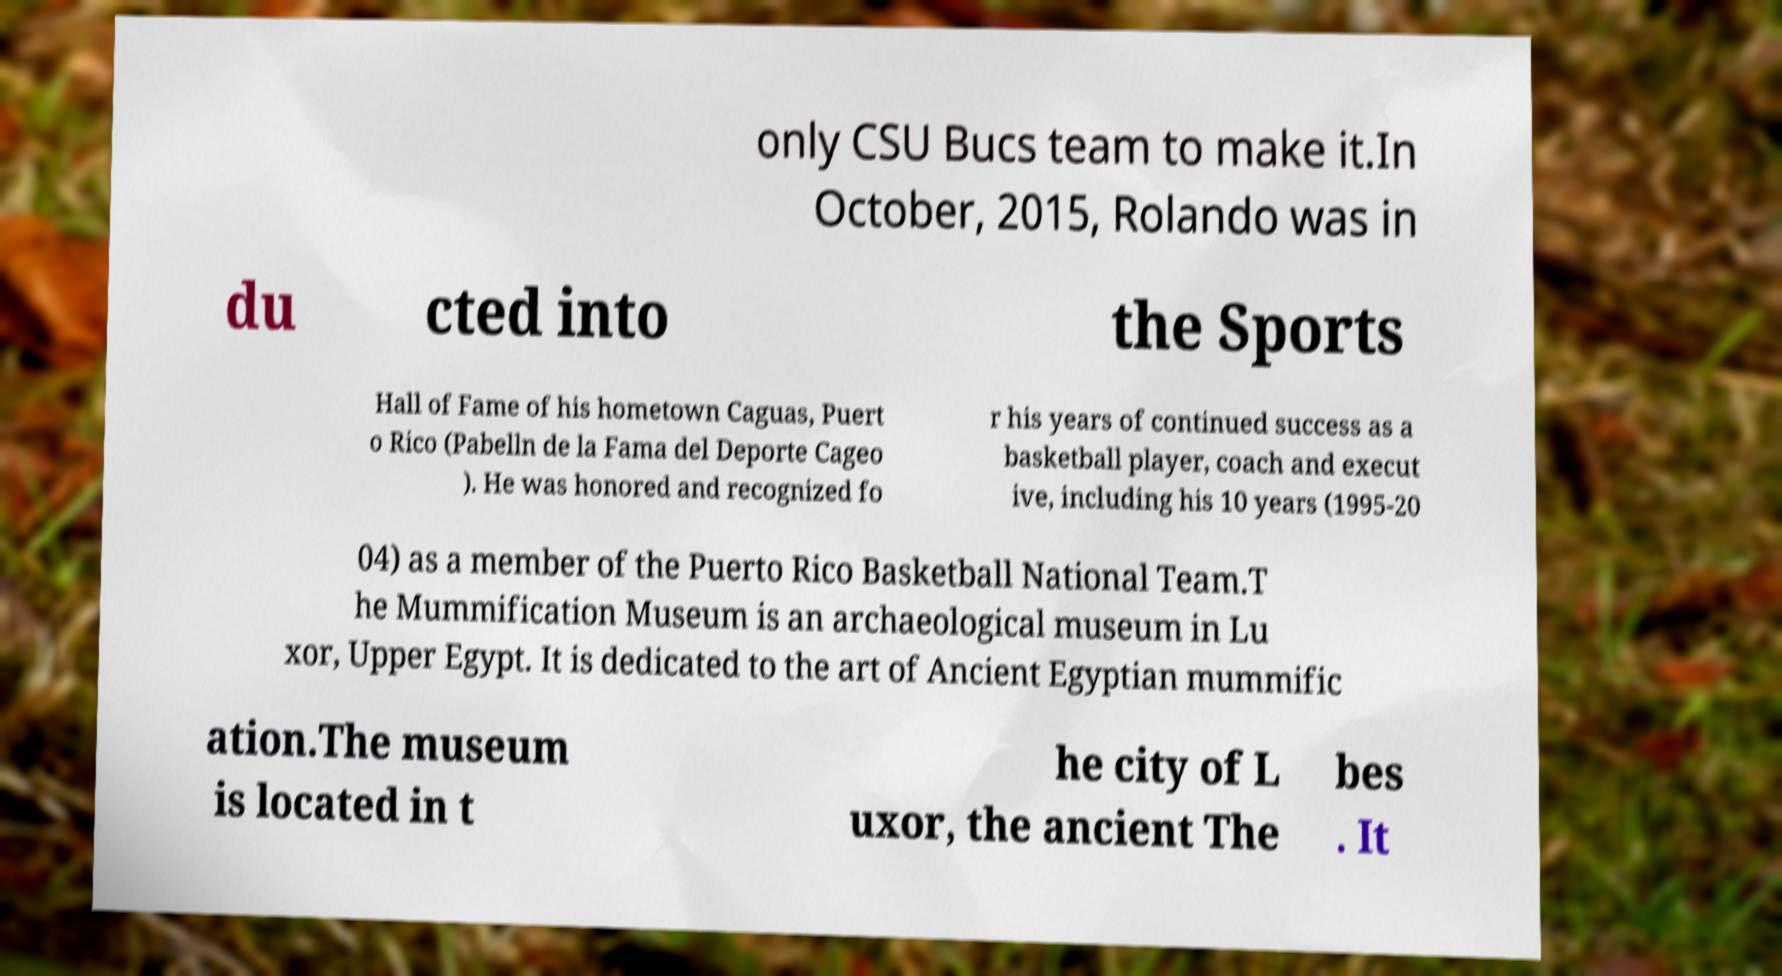Could you assist in decoding the text presented in this image and type it out clearly? only CSU Bucs team to make it.In October, 2015, Rolando was in du cted into the Sports Hall of Fame of his hometown Caguas, Puert o Rico (Pabelln de la Fama del Deporte Cageo ). He was honored and recognized fo r his years of continued success as a basketball player, coach and execut ive, including his 10 years (1995-20 04) as a member of the Puerto Rico Basketball National Team.T he Mummification Museum is an archaeological museum in Lu xor, Upper Egypt. It is dedicated to the art of Ancient Egyptian mummific ation.The museum is located in t he city of L uxor, the ancient The bes . It 